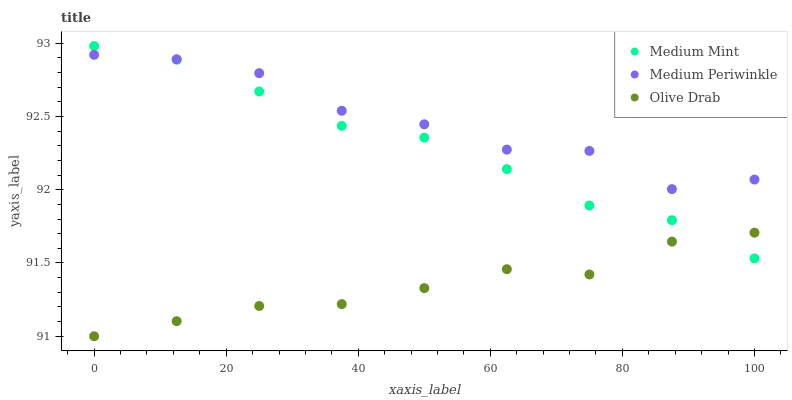Does Olive Drab have the minimum area under the curve?
Answer yes or no. Yes. Does Medium Periwinkle have the maximum area under the curve?
Answer yes or no. Yes. Does Medium Periwinkle have the minimum area under the curve?
Answer yes or no. No. Does Olive Drab have the maximum area under the curve?
Answer yes or no. No. Is Medium Mint the smoothest?
Answer yes or no. Yes. Is Medium Periwinkle the roughest?
Answer yes or no. Yes. Is Olive Drab the smoothest?
Answer yes or no. No. Is Olive Drab the roughest?
Answer yes or no. No. Does Olive Drab have the lowest value?
Answer yes or no. Yes. Does Medium Periwinkle have the lowest value?
Answer yes or no. No. Does Medium Mint have the highest value?
Answer yes or no. Yes. Does Medium Periwinkle have the highest value?
Answer yes or no. No. Is Olive Drab less than Medium Periwinkle?
Answer yes or no. Yes. Is Medium Periwinkle greater than Olive Drab?
Answer yes or no. Yes. Does Medium Periwinkle intersect Medium Mint?
Answer yes or no. Yes. Is Medium Periwinkle less than Medium Mint?
Answer yes or no. No. Is Medium Periwinkle greater than Medium Mint?
Answer yes or no. No. Does Olive Drab intersect Medium Periwinkle?
Answer yes or no. No. 